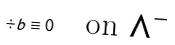<formula> <loc_0><loc_0><loc_500><loc_500>\div b \equiv 0 \quad \text {on $\Lambda^{-}$}</formula> 